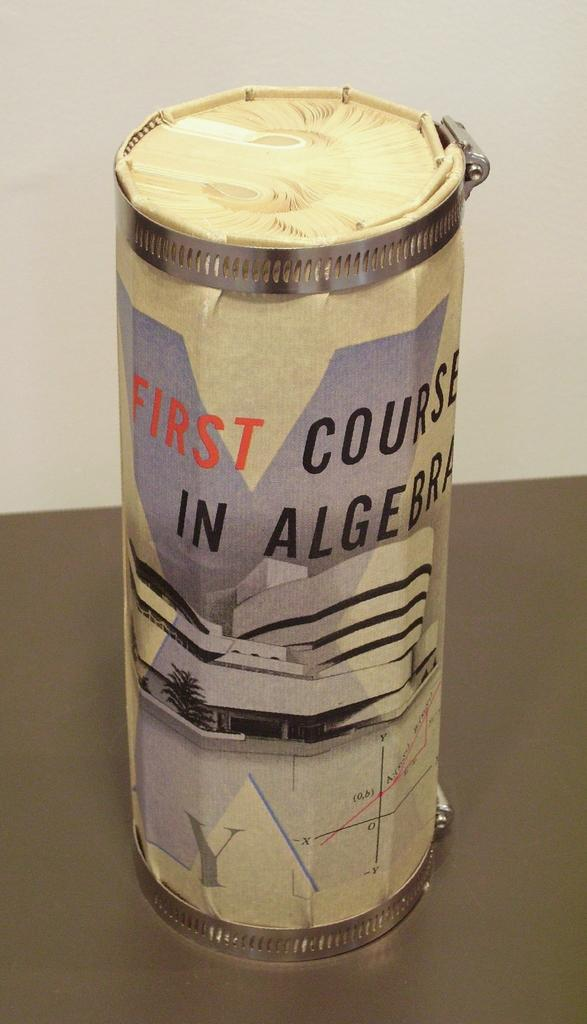<image>
Write a terse but informative summary of the picture. An unusually shaped paper object is bound into a round shape and reads FIRST COURSE IN ALGEBRA on the outside 